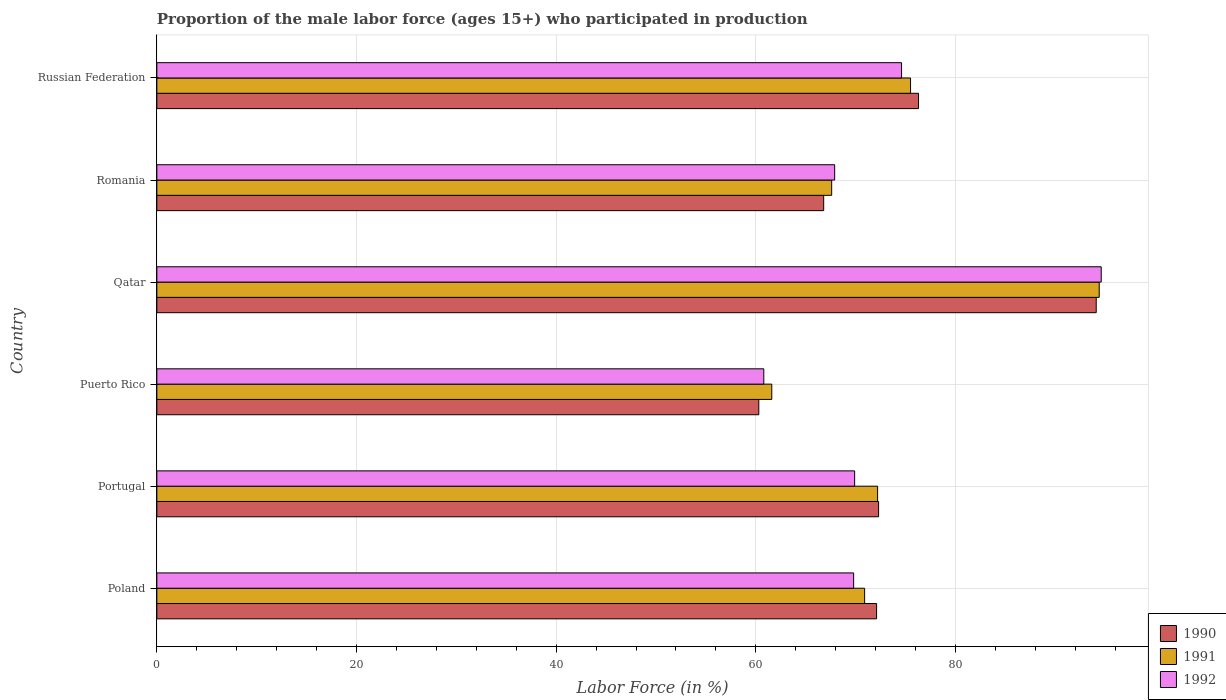Are the number of bars per tick equal to the number of legend labels?
Provide a short and direct response. Yes. Are the number of bars on each tick of the Y-axis equal?
Offer a very short reply. Yes. How many bars are there on the 1st tick from the top?
Offer a terse response. 3. What is the label of the 5th group of bars from the top?
Provide a short and direct response. Portugal. What is the proportion of the male labor force who participated in production in 1992 in Puerto Rico?
Ensure brevity in your answer.  60.8. Across all countries, what is the maximum proportion of the male labor force who participated in production in 1992?
Make the answer very short. 94.6. Across all countries, what is the minimum proportion of the male labor force who participated in production in 1990?
Provide a short and direct response. 60.3. In which country was the proportion of the male labor force who participated in production in 1990 maximum?
Make the answer very short. Qatar. In which country was the proportion of the male labor force who participated in production in 1991 minimum?
Ensure brevity in your answer.  Puerto Rico. What is the total proportion of the male labor force who participated in production in 1992 in the graph?
Keep it short and to the point. 437.6. What is the difference between the proportion of the male labor force who participated in production in 1991 in Russian Federation and the proportion of the male labor force who participated in production in 1990 in Qatar?
Offer a very short reply. -18.6. What is the average proportion of the male labor force who participated in production in 1991 per country?
Make the answer very short. 73.7. What is the difference between the proportion of the male labor force who participated in production in 1990 and proportion of the male labor force who participated in production in 1992 in Romania?
Give a very brief answer. -1.1. In how many countries, is the proportion of the male labor force who participated in production in 1992 greater than 12 %?
Keep it short and to the point. 6. What is the ratio of the proportion of the male labor force who participated in production in 1990 in Portugal to that in Russian Federation?
Provide a succinct answer. 0.95. Is the proportion of the male labor force who participated in production in 1990 in Portugal less than that in Russian Federation?
Provide a short and direct response. Yes. What is the difference between the highest and the lowest proportion of the male labor force who participated in production in 1991?
Your response must be concise. 32.8. In how many countries, is the proportion of the male labor force who participated in production in 1990 greater than the average proportion of the male labor force who participated in production in 1990 taken over all countries?
Give a very brief answer. 2. Is the sum of the proportion of the male labor force who participated in production in 1990 in Puerto Rico and Qatar greater than the maximum proportion of the male labor force who participated in production in 1991 across all countries?
Give a very brief answer. Yes. What does the 1st bar from the bottom in Portugal represents?
Provide a short and direct response. 1990. Is it the case that in every country, the sum of the proportion of the male labor force who participated in production in 1991 and proportion of the male labor force who participated in production in 1992 is greater than the proportion of the male labor force who participated in production in 1990?
Provide a short and direct response. Yes. How many bars are there?
Give a very brief answer. 18. Are all the bars in the graph horizontal?
Make the answer very short. Yes. What is the difference between two consecutive major ticks on the X-axis?
Your response must be concise. 20. Where does the legend appear in the graph?
Keep it short and to the point. Bottom right. What is the title of the graph?
Offer a very short reply. Proportion of the male labor force (ages 15+) who participated in production. What is the label or title of the Y-axis?
Keep it short and to the point. Country. What is the Labor Force (in %) in 1990 in Poland?
Offer a very short reply. 72.1. What is the Labor Force (in %) in 1991 in Poland?
Make the answer very short. 70.9. What is the Labor Force (in %) of 1992 in Poland?
Give a very brief answer. 69.8. What is the Labor Force (in %) of 1990 in Portugal?
Offer a terse response. 72.3. What is the Labor Force (in %) in 1991 in Portugal?
Ensure brevity in your answer.  72.2. What is the Labor Force (in %) of 1992 in Portugal?
Your answer should be very brief. 69.9. What is the Labor Force (in %) in 1990 in Puerto Rico?
Provide a succinct answer. 60.3. What is the Labor Force (in %) of 1991 in Puerto Rico?
Make the answer very short. 61.6. What is the Labor Force (in %) in 1992 in Puerto Rico?
Your answer should be very brief. 60.8. What is the Labor Force (in %) of 1990 in Qatar?
Provide a succinct answer. 94.1. What is the Labor Force (in %) of 1991 in Qatar?
Offer a very short reply. 94.4. What is the Labor Force (in %) in 1992 in Qatar?
Your answer should be compact. 94.6. What is the Labor Force (in %) in 1990 in Romania?
Give a very brief answer. 66.8. What is the Labor Force (in %) of 1991 in Romania?
Offer a terse response. 67.6. What is the Labor Force (in %) of 1992 in Romania?
Ensure brevity in your answer.  67.9. What is the Labor Force (in %) of 1990 in Russian Federation?
Your response must be concise. 76.3. What is the Labor Force (in %) in 1991 in Russian Federation?
Your response must be concise. 75.5. What is the Labor Force (in %) in 1992 in Russian Federation?
Offer a very short reply. 74.6. Across all countries, what is the maximum Labor Force (in %) of 1990?
Keep it short and to the point. 94.1. Across all countries, what is the maximum Labor Force (in %) of 1991?
Provide a short and direct response. 94.4. Across all countries, what is the maximum Labor Force (in %) of 1992?
Keep it short and to the point. 94.6. Across all countries, what is the minimum Labor Force (in %) of 1990?
Provide a succinct answer. 60.3. Across all countries, what is the minimum Labor Force (in %) in 1991?
Make the answer very short. 61.6. Across all countries, what is the minimum Labor Force (in %) in 1992?
Provide a succinct answer. 60.8. What is the total Labor Force (in %) of 1990 in the graph?
Provide a short and direct response. 441.9. What is the total Labor Force (in %) in 1991 in the graph?
Offer a very short reply. 442.2. What is the total Labor Force (in %) of 1992 in the graph?
Keep it short and to the point. 437.6. What is the difference between the Labor Force (in %) of 1992 in Poland and that in Portugal?
Your answer should be very brief. -0.1. What is the difference between the Labor Force (in %) in 1990 in Poland and that in Qatar?
Your answer should be very brief. -22. What is the difference between the Labor Force (in %) of 1991 in Poland and that in Qatar?
Your answer should be compact. -23.5. What is the difference between the Labor Force (in %) of 1992 in Poland and that in Qatar?
Provide a short and direct response. -24.8. What is the difference between the Labor Force (in %) in 1990 in Poland and that in Romania?
Give a very brief answer. 5.3. What is the difference between the Labor Force (in %) of 1992 in Poland and that in Romania?
Provide a short and direct response. 1.9. What is the difference between the Labor Force (in %) in 1991 in Poland and that in Russian Federation?
Offer a very short reply. -4.6. What is the difference between the Labor Force (in %) of 1992 in Poland and that in Russian Federation?
Give a very brief answer. -4.8. What is the difference between the Labor Force (in %) in 1991 in Portugal and that in Puerto Rico?
Your response must be concise. 10.6. What is the difference between the Labor Force (in %) in 1992 in Portugal and that in Puerto Rico?
Your answer should be compact. 9.1. What is the difference between the Labor Force (in %) of 1990 in Portugal and that in Qatar?
Ensure brevity in your answer.  -21.8. What is the difference between the Labor Force (in %) in 1991 in Portugal and that in Qatar?
Offer a very short reply. -22.2. What is the difference between the Labor Force (in %) in 1992 in Portugal and that in Qatar?
Provide a short and direct response. -24.7. What is the difference between the Labor Force (in %) in 1992 in Portugal and that in Romania?
Keep it short and to the point. 2. What is the difference between the Labor Force (in %) of 1991 in Portugal and that in Russian Federation?
Offer a terse response. -3.3. What is the difference between the Labor Force (in %) in 1992 in Portugal and that in Russian Federation?
Your response must be concise. -4.7. What is the difference between the Labor Force (in %) in 1990 in Puerto Rico and that in Qatar?
Your response must be concise. -33.8. What is the difference between the Labor Force (in %) in 1991 in Puerto Rico and that in Qatar?
Your response must be concise. -32.8. What is the difference between the Labor Force (in %) in 1992 in Puerto Rico and that in Qatar?
Make the answer very short. -33.8. What is the difference between the Labor Force (in %) in 1991 in Puerto Rico and that in Romania?
Keep it short and to the point. -6. What is the difference between the Labor Force (in %) of 1992 in Puerto Rico and that in Romania?
Provide a short and direct response. -7.1. What is the difference between the Labor Force (in %) of 1990 in Puerto Rico and that in Russian Federation?
Your answer should be compact. -16. What is the difference between the Labor Force (in %) in 1990 in Qatar and that in Romania?
Your answer should be very brief. 27.3. What is the difference between the Labor Force (in %) of 1991 in Qatar and that in Romania?
Keep it short and to the point. 26.8. What is the difference between the Labor Force (in %) of 1992 in Qatar and that in Romania?
Keep it short and to the point. 26.7. What is the difference between the Labor Force (in %) of 1992 in Qatar and that in Russian Federation?
Your answer should be compact. 20. What is the difference between the Labor Force (in %) in 1990 in Romania and that in Russian Federation?
Keep it short and to the point. -9.5. What is the difference between the Labor Force (in %) of 1992 in Romania and that in Russian Federation?
Your answer should be very brief. -6.7. What is the difference between the Labor Force (in %) of 1991 in Poland and the Labor Force (in %) of 1992 in Portugal?
Your answer should be very brief. 1. What is the difference between the Labor Force (in %) in 1990 in Poland and the Labor Force (in %) in 1991 in Qatar?
Make the answer very short. -22.3. What is the difference between the Labor Force (in %) of 1990 in Poland and the Labor Force (in %) of 1992 in Qatar?
Offer a very short reply. -22.5. What is the difference between the Labor Force (in %) in 1991 in Poland and the Labor Force (in %) in 1992 in Qatar?
Your response must be concise. -23.7. What is the difference between the Labor Force (in %) of 1990 in Poland and the Labor Force (in %) of 1991 in Romania?
Provide a short and direct response. 4.5. What is the difference between the Labor Force (in %) in 1991 in Poland and the Labor Force (in %) in 1992 in Romania?
Provide a short and direct response. 3. What is the difference between the Labor Force (in %) of 1990 in Poland and the Labor Force (in %) of 1991 in Russian Federation?
Keep it short and to the point. -3.4. What is the difference between the Labor Force (in %) of 1990 in Poland and the Labor Force (in %) of 1992 in Russian Federation?
Ensure brevity in your answer.  -2.5. What is the difference between the Labor Force (in %) of 1991 in Poland and the Labor Force (in %) of 1992 in Russian Federation?
Provide a succinct answer. -3.7. What is the difference between the Labor Force (in %) of 1990 in Portugal and the Labor Force (in %) of 1991 in Puerto Rico?
Provide a short and direct response. 10.7. What is the difference between the Labor Force (in %) in 1990 in Portugal and the Labor Force (in %) in 1992 in Puerto Rico?
Ensure brevity in your answer.  11.5. What is the difference between the Labor Force (in %) in 1991 in Portugal and the Labor Force (in %) in 1992 in Puerto Rico?
Your answer should be very brief. 11.4. What is the difference between the Labor Force (in %) of 1990 in Portugal and the Labor Force (in %) of 1991 in Qatar?
Provide a short and direct response. -22.1. What is the difference between the Labor Force (in %) of 1990 in Portugal and the Labor Force (in %) of 1992 in Qatar?
Your answer should be compact. -22.3. What is the difference between the Labor Force (in %) in 1991 in Portugal and the Labor Force (in %) in 1992 in Qatar?
Provide a succinct answer. -22.4. What is the difference between the Labor Force (in %) of 1990 in Portugal and the Labor Force (in %) of 1992 in Russian Federation?
Offer a terse response. -2.3. What is the difference between the Labor Force (in %) in 1990 in Puerto Rico and the Labor Force (in %) in 1991 in Qatar?
Your answer should be compact. -34.1. What is the difference between the Labor Force (in %) of 1990 in Puerto Rico and the Labor Force (in %) of 1992 in Qatar?
Your response must be concise. -34.3. What is the difference between the Labor Force (in %) in 1991 in Puerto Rico and the Labor Force (in %) in 1992 in Qatar?
Provide a succinct answer. -33. What is the difference between the Labor Force (in %) in 1990 in Puerto Rico and the Labor Force (in %) in 1991 in Romania?
Your answer should be compact. -7.3. What is the difference between the Labor Force (in %) in 1990 in Puerto Rico and the Labor Force (in %) in 1991 in Russian Federation?
Offer a very short reply. -15.2. What is the difference between the Labor Force (in %) of 1990 in Puerto Rico and the Labor Force (in %) of 1992 in Russian Federation?
Make the answer very short. -14.3. What is the difference between the Labor Force (in %) in 1990 in Qatar and the Labor Force (in %) in 1992 in Romania?
Make the answer very short. 26.2. What is the difference between the Labor Force (in %) in 1991 in Qatar and the Labor Force (in %) in 1992 in Russian Federation?
Provide a succinct answer. 19.8. What is the difference between the Labor Force (in %) in 1990 in Romania and the Labor Force (in %) in 1991 in Russian Federation?
Offer a very short reply. -8.7. What is the difference between the Labor Force (in %) of 1991 in Romania and the Labor Force (in %) of 1992 in Russian Federation?
Ensure brevity in your answer.  -7. What is the average Labor Force (in %) of 1990 per country?
Your response must be concise. 73.65. What is the average Labor Force (in %) of 1991 per country?
Offer a terse response. 73.7. What is the average Labor Force (in %) of 1992 per country?
Offer a terse response. 72.93. What is the difference between the Labor Force (in %) in 1990 and Labor Force (in %) in 1991 in Poland?
Your answer should be very brief. 1.2. What is the difference between the Labor Force (in %) in 1990 and Labor Force (in %) in 1991 in Puerto Rico?
Your answer should be very brief. -1.3. What is the difference between the Labor Force (in %) of 1991 and Labor Force (in %) of 1992 in Puerto Rico?
Provide a succinct answer. 0.8. What is the difference between the Labor Force (in %) in 1990 and Labor Force (in %) in 1991 in Qatar?
Offer a very short reply. -0.3. What is the difference between the Labor Force (in %) in 1991 and Labor Force (in %) in 1992 in Qatar?
Keep it short and to the point. -0.2. What is the difference between the Labor Force (in %) in 1991 and Labor Force (in %) in 1992 in Romania?
Give a very brief answer. -0.3. What is the difference between the Labor Force (in %) of 1991 and Labor Force (in %) of 1992 in Russian Federation?
Give a very brief answer. 0.9. What is the ratio of the Labor Force (in %) of 1990 in Poland to that in Portugal?
Provide a short and direct response. 1. What is the ratio of the Labor Force (in %) of 1992 in Poland to that in Portugal?
Keep it short and to the point. 1. What is the ratio of the Labor Force (in %) in 1990 in Poland to that in Puerto Rico?
Your response must be concise. 1.2. What is the ratio of the Labor Force (in %) of 1991 in Poland to that in Puerto Rico?
Offer a very short reply. 1.15. What is the ratio of the Labor Force (in %) of 1992 in Poland to that in Puerto Rico?
Make the answer very short. 1.15. What is the ratio of the Labor Force (in %) in 1990 in Poland to that in Qatar?
Offer a terse response. 0.77. What is the ratio of the Labor Force (in %) in 1991 in Poland to that in Qatar?
Keep it short and to the point. 0.75. What is the ratio of the Labor Force (in %) of 1992 in Poland to that in Qatar?
Give a very brief answer. 0.74. What is the ratio of the Labor Force (in %) of 1990 in Poland to that in Romania?
Provide a succinct answer. 1.08. What is the ratio of the Labor Force (in %) of 1991 in Poland to that in Romania?
Provide a short and direct response. 1.05. What is the ratio of the Labor Force (in %) of 1992 in Poland to that in Romania?
Provide a short and direct response. 1.03. What is the ratio of the Labor Force (in %) in 1990 in Poland to that in Russian Federation?
Make the answer very short. 0.94. What is the ratio of the Labor Force (in %) in 1991 in Poland to that in Russian Federation?
Keep it short and to the point. 0.94. What is the ratio of the Labor Force (in %) in 1992 in Poland to that in Russian Federation?
Make the answer very short. 0.94. What is the ratio of the Labor Force (in %) in 1990 in Portugal to that in Puerto Rico?
Make the answer very short. 1.2. What is the ratio of the Labor Force (in %) in 1991 in Portugal to that in Puerto Rico?
Provide a short and direct response. 1.17. What is the ratio of the Labor Force (in %) of 1992 in Portugal to that in Puerto Rico?
Offer a terse response. 1.15. What is the ratio of the Labor Force (in %) of 1990 in Portugal to that in Qatar?
Provide a succinct answer. 0.77. What is the ratio of the Labor Force (in %) in 1991 in Portugal to that in Qatar?
Provide a succinct answer. 0.76. What is the ratio of the Labor Force (in %) of 1992 in Portugal to that in Qatar?
Ensure brevity in your answer.  0.74. What is the ratio of the Labor Force (in %) in 1990 in Portugal to that in Romania?
Provide a succinct answer. 1.08. What is the ratio of the Labor Force (in %) in 1991 in Portugal to that in Romania?
Offer a terse response. 1.07. What is the ratio of the Labor Force (in %) of 1992 in Portugal to that in Romania?
Offer a very short reply. 1.03. What is the ratio of the Labor Force (in %) in 1990 in Portugal to that in Russian Federation?
Keep it short and to the point. 0.95. What is the ratio of the Labor Force (in %) of 1991 in Portugal to that in Russian Federation?
Give a very brief answer. 0.96. What is the ratio of the Labor Force (in %) in 1992 in Portugal to that in Russian Federation?
Offer a terse response. 0.94. What is the ratio of the Labor Force (in %) of 1990 in Puerto Rico to that in Qatar?
Give a very brief answer. 0.64. What is the ratio of the Labor Force (in %) of 1991 in Puerto Rico to that in Qatar?
Give a very brief answer. 0.65. What is the ratio of the Labor Force (in %) in 1992 in Puerto Rico to that in Qatar?
Make the answer very short. 0.64. What is the ratio of the Labor Force (in %) in 1990 in Puerto Rico to that in Romania?
Your response must be concise. 0.9. What is the ratio of the Labor Force (in %) of 1991 in Puerto Rico to that in Romania?
Offer a terse response. 0.91. What is the ratio of the Labor Force (in %) in 1992 in Puerto Rico to that in Romania?
Provide a short and direct response. 0.9. What is the ratio of the Labor Force (in %) of 1990 in Puerto Rico to that in Russian Federation?
Keep it short and to the point. 0.79. What is the ratio of the Labor Force (in %) of 1991 in Puerto Rico to that in Russian Federation?
Offer a very short reply. 0.82. What is the ratio of the Labor Force (in %) of 1992 in Puerto Rico to that in Russian Federation?
Your response must be concise. 0.81. What is the ratio of the Labor Force (in %) in 1990 in Qatar to that in Romania?
Provide a short and direct response. 1.41. What is the ratio of the Labor Force (in %) in 1991 in Qatar to that in Romania?
Provide a short and direct response. 1.4. What is the ratio of the Labor Force (in %) in 1992 in Qatar to that in Romania?
Provide a short and direct response. 1.39. What is the ratio of the Labor Force (in %) of 1990 in Qatar to that in Russian Federation?
Keep it short and to the point. 1.23. What is the ratio of the Labor Force (in %) in 1991 in Qatar to that in Russian Federation?
Your response must be concise. 1.25. What is the ratio of the Labor Force (in %) of 1992 in Qatar to that in Russian Federation?
Ensure brevity in your answer.  1.27. What is the ratio of the Labor Force (in %) in 1990 in Romania to that in Russian Federation?
Offer a very short reply. 0.88. What is the ratio of the Labor Force (in %) in 1991 in Romania to that in Russian Federation?
Ensure brevity in your answer.  0.9. What is the ratio of the Labor Force (in %) in 1992 in Romania to that in Russian Federation?
Keep it short and to the point. 0.91. What is the difference between the highest and the second highest Labor Force (in %) in 1990?
Keep it short and to the point. 17.8. What is the difference between the highest and the lowest Labor Force (in %) in 1990?
Keep it short and to the point. 33.8. What is the difference between the highest and the lowest Labor Force (in %) in 1991?
Your response must be concise. 32.8. What is the difference between the highest and the lowest Labor Force (in %) in 1992?
Give a very brief answer. 33.8. 